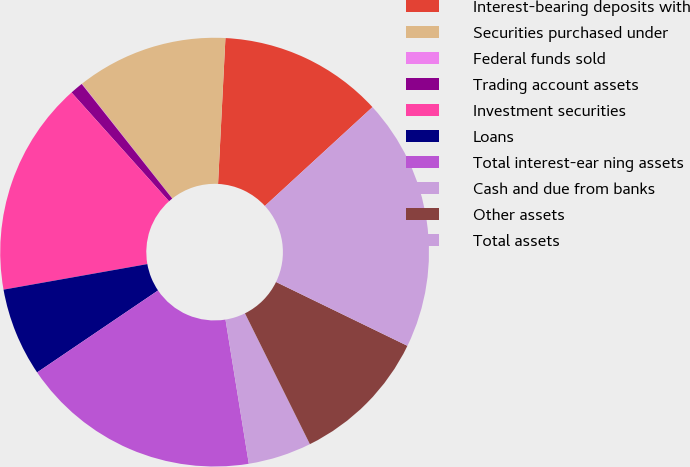Convert chart to OTSL. <chart><loc_0><loc_0><loc_500><loc_500><pie_chart><fcel>Interest-bearing deposits with<fcel>Securities purchased under<fcel>Federal funds sold<fcel>Trading account assets<fcel>Investment securities<fcel>Loans<fcel>Total interest-ear ning assets<fcel>Cash and due from banks<fcel>Other assets<fcel>Total assets<nl><fcel>12.37%<fcel>11.42%<fcel>0.03%<fcel>0.98%<fcel>16.17%<fcel>6.68%<fcel>18.07%<fcel>4.78%<fcel>10.47%<fcel>19.02%<nl></chart> 